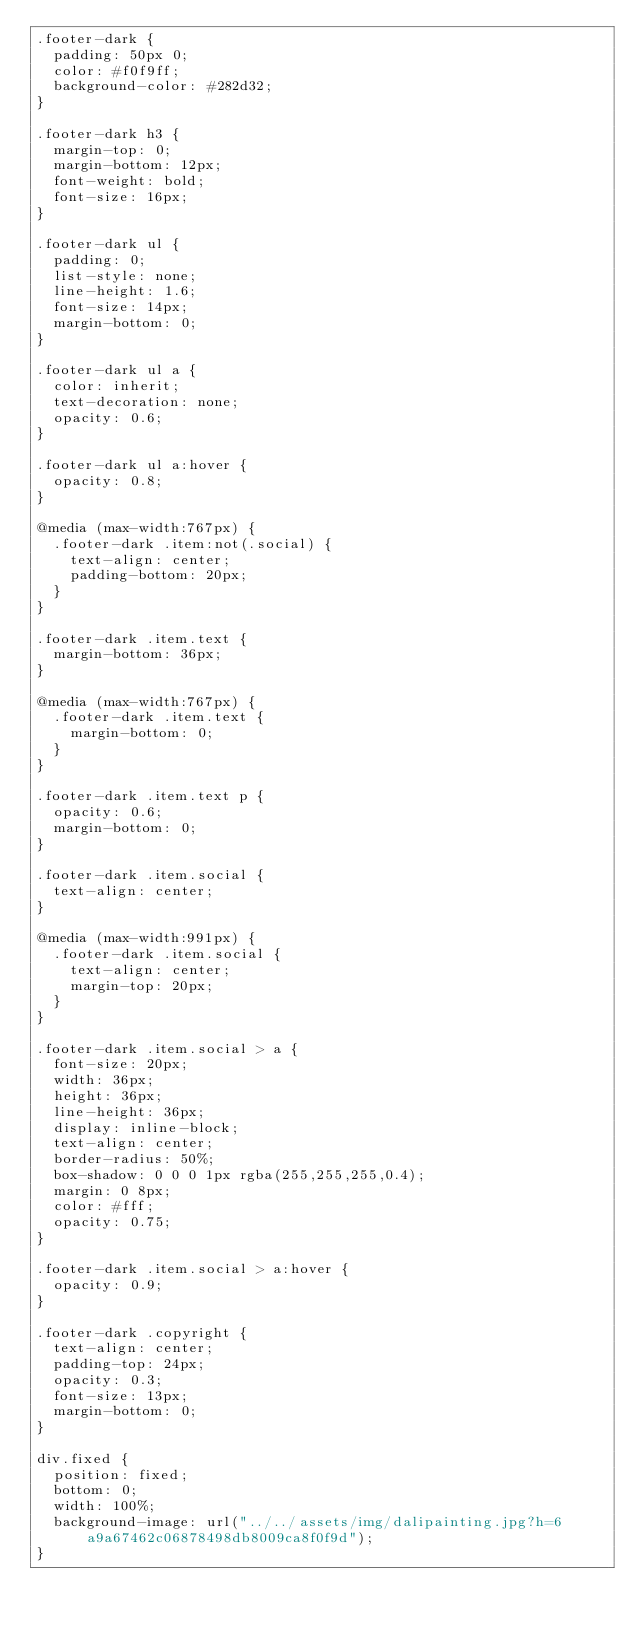<code> <loc_0><loc_0><loc_500><loc_500><_CSS_>.footer-dark {
  padding: 50px 0;
  color: #f0f9ff;
  background-color: #282d32;
}

.footer-dark h3 {
  margin-top: 0;
  margin-bottom: 12px;
  font-weight: bold;
  font-size: 16px;
}

.footer-dark ul {
  padding: 0;
  list-style: none;
  line-height: 1.6;
  font-size: 14px;
  margin-bottom: 0;
}

.footer-dark ul a {
  color: inherit;
  text-decoration: none;
  opacity: 0.6;
}

.footer-dark ul a:hover {
  opacity: 0.8;
}

@media (max-width:767px) {
  .footer-dark .item:not(.social) {
    text-align: center;
    padding-bottom: 20px;
  }
}

.footer-dark .item.text {
  margin-bottom: 36px;
}

@media (max-width:767px) {
  .footer-dark .item.text {
    margin-bottom: 0;
  }
}

.footer-dark .item.text p {
  opacity: 0.6;
  margin-bottom: 0;
}

.footer-dark .item.social {
  text-align: center;
}

@media (max-width:991px) {
  .footer-dark .item.social {
    text-align: center;
    margin-top: 20px;
  }
}

.footer-dark .item.social > a {
  font-size: 20px;
  width: 36px;
  height: 36px;
  line-height: 36px;
  display: inline-block;
  text-align: center;
  border-radius: 50%;
  box-shadow: 0 0 0 1px rgba(255,255,255,0.4);
  margin: 0 8px;
  color: #fff;
  opacity: 0.75;
}

.footer-dark .item.social > a:hover {
  opacity: 0.9;
}

.footer-dark .copyright {
  text-align: center;
  padding-top: 24px;
  opacity: 0.3;
  font-size: 13px;
  margin-bottom: 0;
}

div.fixed {
  position: fixed;
  bottom: 0;
  width: 100%;
  background-image: url("../../assets/img/dalipainting.jpg?h=6a9a67462c06878498db8009ca8f0f9d");
}

</code> 